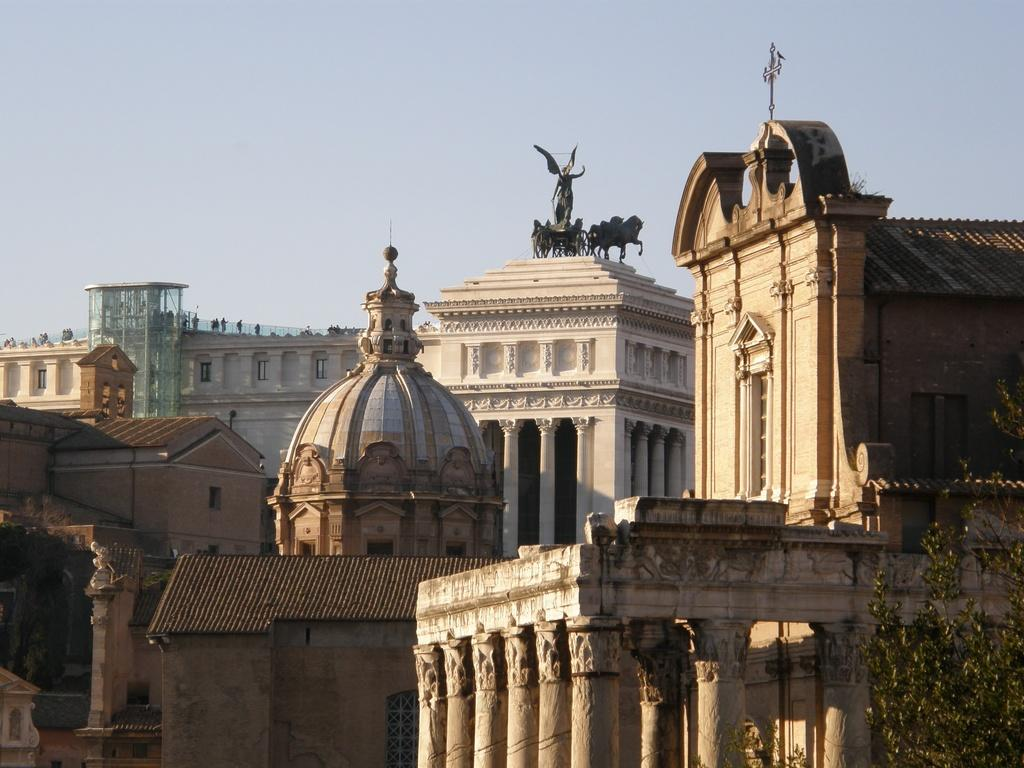What structures are located at the bottom of the image? There are buildings and statues at the bottom of the image. What can be seen in the sky at the top of the image? Sky is visible at the top of the image. What type of vegetation is on the right side of the image? There are trees on the right side of the image. Where are the scissors located in the image? There are no scissors present in the image. What type of boot is visible on the left side of the image? There is no boot present in the image. 